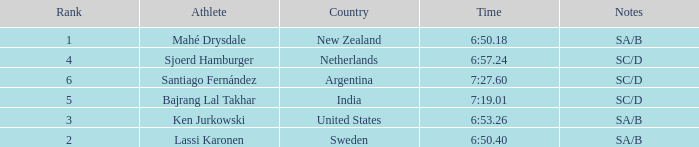What is the highest rank for the team that raced a time of 6:50.40? 2.0. 